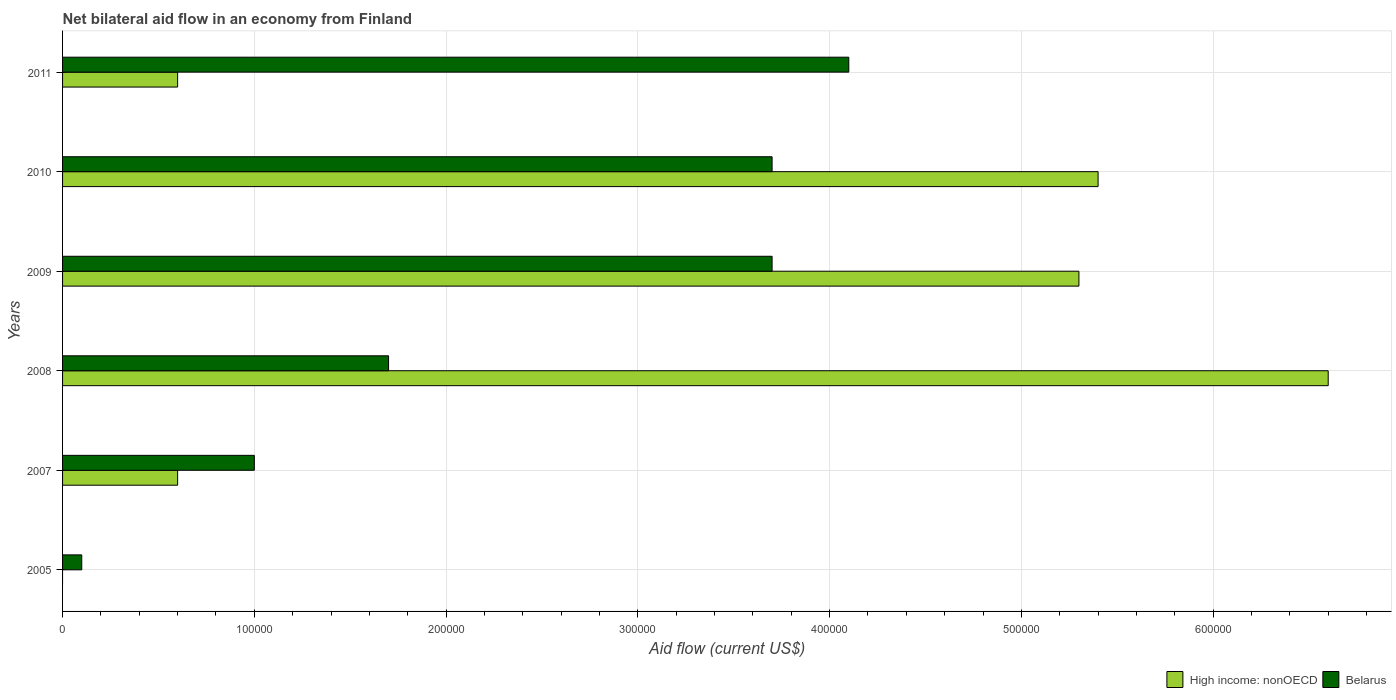Are the number of bars per tick equal to the number of legend labels?
Make the answer very short. No. Are the number of bars on each tick of the Y-axis equal?
Provide a succinct answer. No. How many bars are there on the 6th tick from the top?
Give a very brief answer. 1. How many bars are there on the 3rd tick from the bottom?
Offer a very short reply. 2. What is the label of the 5th group of bars from the top?
Offer a very short reply. 2007. In how many cases, is the number of bars for a given year not equal to the number of legend labels?
Make the answer very short. 1. What is the net bilateral aid flow in High income: nonOECD in 2010?
Make the answer very short. 5.40e+05. What is the total net bilateral aid flow in Belarus in the graph?
Offer a very short reply. 1.43e+06. What is the difference between the net bilateral aid flow in High income: nonOECD in 2010 and the net bilateral aid flow in Belarus in 2008?
Give a very brief answer. 3.70e+05. What is the average net bilateral aid flow in Belarus per year?
Give a very brief answer. 2.38e+05. What is the ratio of the net bilateral aid flow in Belarus in 2005 to that in 2011?
Provide a short and direct response. 0.02. Is the net bilateral aid flow in Belarus in 2008 less than that in 2011?
Provide a succinct answer. Yes. How many bars are there?
Provide a succinct answer. 11. How many years are there in the graph?
Your response must be concise. 6. What is the difference between two consecutive major ticks on the X-axis?
Your answer should be compact. 1.00e+05. Are the values on the major ticks of X-axis written in scientific E-notation?
Ensure brevity in your answer.  No. Does the graph contain grids?
Your answer should be very brief. Yes. Where does the legend appear in the graph?
Offer a terse response. Bottom right. How many legend labels are there?
Offer a terse response. 2. What is the title of the graph?
Keep it short and to the point. Net bilateral aid flow in an economy from Finland. Does "Oman" appear as one of the legend labels in the graph?
Provide a succinct answer. No. What is the Aid flow (current US$) in High income: nonOECD in 2005?
Offer a very short reply. 0. What is the Aid flow (current US$) of High income: nonOECD in 2007?
Your response must be concise. 6.00e+04. What is the Aid flow (current US$) of High income: nonOECD in 2008?
Provide a short and direct response. 6.60e+05. What is the Aid flow (current US$) in Belarus in 2008?
Offer a very short reply. 1.70e+05. What is the Aid flow (current US$) in High income: nonOECD in 2009?
Make the answer very short. 5.30e+05. What is the Aid flow (current US$) of Belarus in 2009?
Provide a succinct answer. 3.70e+05. What is the Aid flow (current US$) of High income: nonOECD in 2010?
Provide a succinct answer. 5.40e+05. What is the Aid flow (current US$) of High income: nonOECD in 2011?
Give a very brief answer. 6.00e+04. What is the Aid flow (current US$) in Belarus in 2011?
Your answer should be very brief. 4.10e+05. Across all years, what is the maximum Aid flow (current US$) of Belarus?
Ensure brevity in your answer.  4.10e+05. What is the total Aid flow (current US$) in High income: nonOECD in the graph?
Your answer should be very brief. 1.85e+06. What is the total Aid flow (current US$) in Belarus in the graph?
Make the answer very short. 1.43e+06. What is the difference between the Aid flow (current US$) of Belarus in 2005 and that in 2008?
Give a very brief answer. -1.60e+05. What is the difference between the Aid flow (current US$) of Belarus in 2005 and that in 2009?
Offer a very short reply. -3.60e+05. What is the difference between the Aid flow (current US$) in Belarus in 2005 and that in 2010?
Offer a terse response. -3.60e+05. What is the difference between the Aid flow (current US$) in Belarus in 2005 and that in 2011?
Your answer should be very brief. -4.00e+05. What is the difference between the Aid flow (current US$) of High income: nonOECD in 2007 and that in 2008?
Your response must be concise. -6.00e+05. What is the difference between the Aid flow (current US$) in Belarus in 2007 and that in 2008?
Your answer should be very brief. -7.00e+04. What is the difference between the Aid flow (current US$) in High income: nonOECD in 2007 and that in 2009?
Your answer should be very brief. -4.70e+05. What is the difference between the Aid flow (current US$) of High income: nonOECD in 2007 and that in 2010?
Your answer should be very brief. -4.80e+05. What is the difference between the Aid flow (current US$) of Belarus in 2007 and that in 2010?
Provide a succinct answer. -2.70e+05. What is the difference between the Aid flow (current US$) in Belarus in 2007 and that in 2011?
Your answer should be very brief. -3.10e+05. What is the difference between the Aid flow (current US$) of High income: nonOECD in 2008 and that in 2009?
Keep it short and to the point. 1.30e+05. What is the difference between the Aid flow (current US$) of Belarus in 2008 and that in 2010?
Provide a short and direct response. -2.00e+05. What is the difference between the Aid flow (current US$) in High income: nonOECD in 2009 and that in 2010?
Ensure brevity in your answer.  -10000. What is the difference between the Aid flow (current US$) in Belarus in 2009 and that in 2010?
Your response must be concise. 0. What is the difference between the Aid flow (current US$) of High income: nonOECD in 2009 and that in 2011?
Your response must be concise. 4.70e+05. What is the difference between the Aid flow (current US$) in High income: nonOECD in 2010 and that in 2011?
Provide a short and direct response. 4.80e+05. What is the difference between the Aid flow (current US$) of High income: nonOECD in 2007 and the Aid flow (current US$) of Belarus in 2009?
Make the answer very short. -3.10e+05. What is the difference between the Aid flow (current US$) of High income: nonOECD in 2007 and the Aid flow (current US$) of Belarus in 2010?
Ensure brevity in your answer.  -3.10e+05. What is the difference between the Aid flow (current US$) of High income: nonOECD in 2007 and the Aid flow (current US$) of Belarus in 2011?
Offer a very short reply. -3.50e+05. What is the difference between the Aid flow (current US$) of High income: nonOECD in 2009 and the Aid flow (current US$) of Belarus in 2011?
Keep it short and to the point. 1.20e+05. What is the average Aid flow (current US$) of High income: nonOECD per year?
Give a very brief answer. 3.08e+05. What is the average Aid flow (current US$) in Belarus per year?
Make the answer very short. 2.38e+05. In the year 2007, what is the difference between the Aid flow (current US$) of High income: nonOECD and Aid flow (current US$) of Belarus?
Offer a terse response. -4.00e+04. In the year 2008, what is the difference between the Aid flow (current US$) in High income: nonOECD and Aid flow (current US$) in Belarus?
Keep it short and to the point. 4.90e+05. In the year 2010, what is the difference between the Aid flow (current US$) in High income: nonOECD and Aid flow (current US$) in Belarus?
Provide a succinct answer. 1.70e+05. In the year 2011, what is the difference between the Aid flow (current US$) in High income: nonOECD and Aid flow (current US$) in Belarus?
Give a very brief answer. -3.50e+05. What is the ratio of the Aid flow (current US$) of Belarus in 2005 to that in 2007?
Your answer should be compact. 0.1. What is the ratio of the Aid flow (current US$) in Belarus in 2005 to that in 2008?
Your answer should be very brief. 0.06. What is the ratio of the Aid flow (current US$) in Belarus in 2005 to that in 2009?
Make the answer very short. 0.03. What is the ratio of the Aid flow (current US$) in Belarus in 2005 to that in 2010?
Give a very brief answer. 0.03. What is the ratio of the Aid flow (current US$) of Belarus in 2005 to that in 2011?
Your answer should be very brief. 0.02. What is the ratio of the Aid flow (current US$) in High income: nonOECD in 2007 to that in 2008?
Your response must be concise. 0.09. What is the ratio of the Aid flow (current US$) of Belarus in 2007 to that in 2008?
Give a very brief answer. 0.59. What is the ratio of the Aid flow (current US$) of High income: nonOECD in 2007 to that in 2009?
Offer a terse response. 0.11. What is the ratio of the Aid flow (current US$) of Belarus in 2007 to that in 2009?
Make the answer very short. 0.27. What is the ratio of the Aid flow (current US$) of Belarus in 2007 to that in 2010?
Your answer should be very brief. 0.27. What is the ratio of the Aid flow (current US$) of Belarus in 2007 to that in 2011?
Ensure brevity in your answer.  0.24. What is the ratio of the Aid flow (current US$) of High income: nonOECD in 2008 to that in 2009?
Your answer should be very brief. 1.25. What is the ratio of the Aid flow (current US$) of Belarus in 2008 to that in 2009?
Your answer should be very brief. 0.46. What is the ratio of the Aid flow (current US$) of High income: nonOECD in 2008 to that in 2010?
Offer a terse response. 1.22. What is the ratio of the Aid flow (current US$) in Belarus in 2008 to that in 2010?
Your response must be concise. 0.46. What is the ratio of the Aid flow (current US$) of High income: nonOECD in 2008 to that in 2011?
Your response must be concise. 11. What is the ratio of the Aid flow (current US$) in Belarus in 2008 to that in 2011?
Ensure brevity in your answer.  0.41. What is the ratio of the Aid flow (current US$) in High income: nonOECD in 2009 to that in 2010?
Provide a short and direct response. 0.98. What is the ratio of the Aid flow (current US$) in Belarus in 2009 to that in 2010?
Keep it short and to the point. 1. What is the ratio of the Aid flow (current US$) in High income: nonOECD in 2009 to that in 2011?
Your answer should be compact. 8.83. What is the ratio of the Aid flow (current US$) of Belarus in 2009 to that in 2011?
Keep it short and to the point. 0.9. What is the ratio of the Aid flow (current US$) in High income: nonOECD in 2010 to that in 2011?
Provide a short and direct response. 9. What is the ratio of the Aid flow (current US$) in Belarus in 2010 to that in 2011?
Ensure brevity in your answer.  0.9. What is the difference between the highest and the second highest Aid flow (current US$) of High income: nonOECD?
Your answer should be compact. 1.20e+05. What is the difference between the highest and the lowest Aid flow (current US$) in High income: nonOECD?
Your response must be concise. 6.60e+05. What is the difference between the highest and the lowest Aid flow (current US$) of Belarus?
Ensure brevity in your answer.  4.00e+05. 